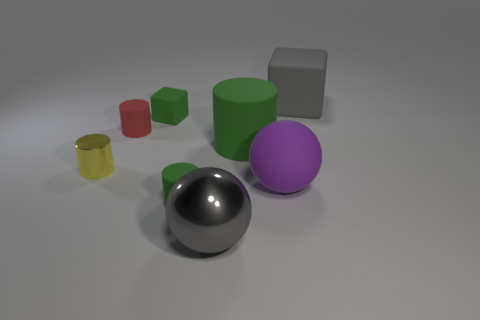The matte thing that is the same color as the shiny sphere is what size?
Make the answer very short. Large. Is the shape of the red matte thing the same as the green rubber object on the right side of the gray ball?
Your answer should be very brief. Yes. Do the rubber cylinder in front of the big purple thing and the cube that is to the left of the purple rubber ball have the same color?
Provide a short and direct response. Yes. What shape is the big shiny object that is the same color as the big rubber cube?
Keep it short and to the point. Sphere. What is the color of the other matte object that is the same shape as the big gray matte object?
Offer a very short reply. Green. Is there anything else of the same color as the shiny sphere?
Keep it short and to the point. Yes. Is there a green object of the same shape as the red object?
Keep it short and to the point. Yes. What is the color of the large thing that is behind the small red rubber object?
Offer a terse response. Gray. Is the size of the thing right of the large purple object the same as the block that is to the left of the large block?
Keep it short and to the point. No. Is there a rubber cylinder of the same size as the rubber ball?
Keep it short and to the point. Yes. 